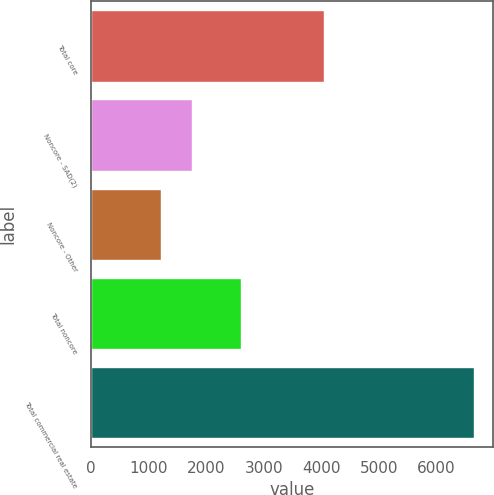Convert chart to OTSL. <chart><loc_0><loc_0><loc_500><loc_500><bar_chart><fcel>Total core<fcel>Noncore - SAD(2)<fcel>Noncore - Other<fcel>Total noncore<fcel>Total commercial real estate<nl><fcel>4042<fcel>1753.2<fcel>1209<fcel>2609<fcel>6651<nl></chart> 